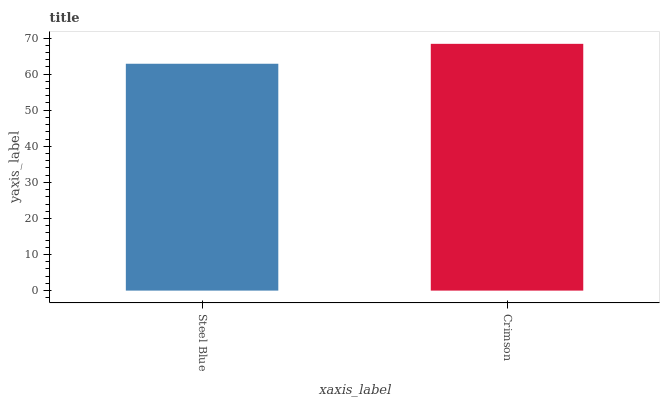Is Steel Blue the minimum?
Answer yes or no. Yes. Is Crimson the maximum?
Answer yes or no. Yes. Is Crimson the minimum?
Answer yes or no. No. Is Crimson greater than Steel Blue?
Answer yes or no. Yes. Is Steel Blue less than Crimson?
Answer yes or no. Yes. Is Steel Blue greater than Crimson?
Answer yes or no. No. Is Crimson less than Steel Blue?
Answer yes or no. No. Is Crimson the high median?
Answer yes or no. Yes. Is Steel Blue the low median?
Answer yes or no. Yes. Is Steel Blue the high median?
Answer yes or no. No. Is Crimson the low median?
Answer yes or no. No. 